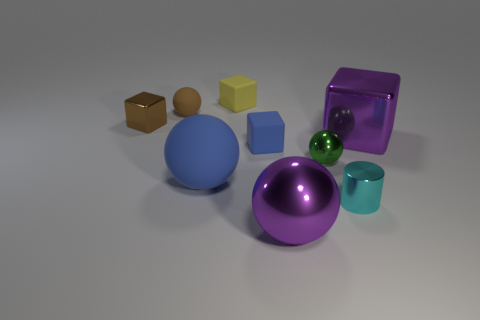What materials are represented by the objects in this image? The objects in this image appear to represent a variety of materials. There's a glossy purple sphere and a transparent green sphere that could be glass or some shiny plastic. The large blue sphere has a matte finish, likely representing a rough or unpolished surface. The small yellow and the big purple cubes look matte, perhaps like painted wood or plastic. The brown cube might represent a material like cardboard or wood, while the cyan cylinder has a reflective surface, suggesting a metallic material. Finally, the teal cylinder could be ceramic or a matte painted surface. 